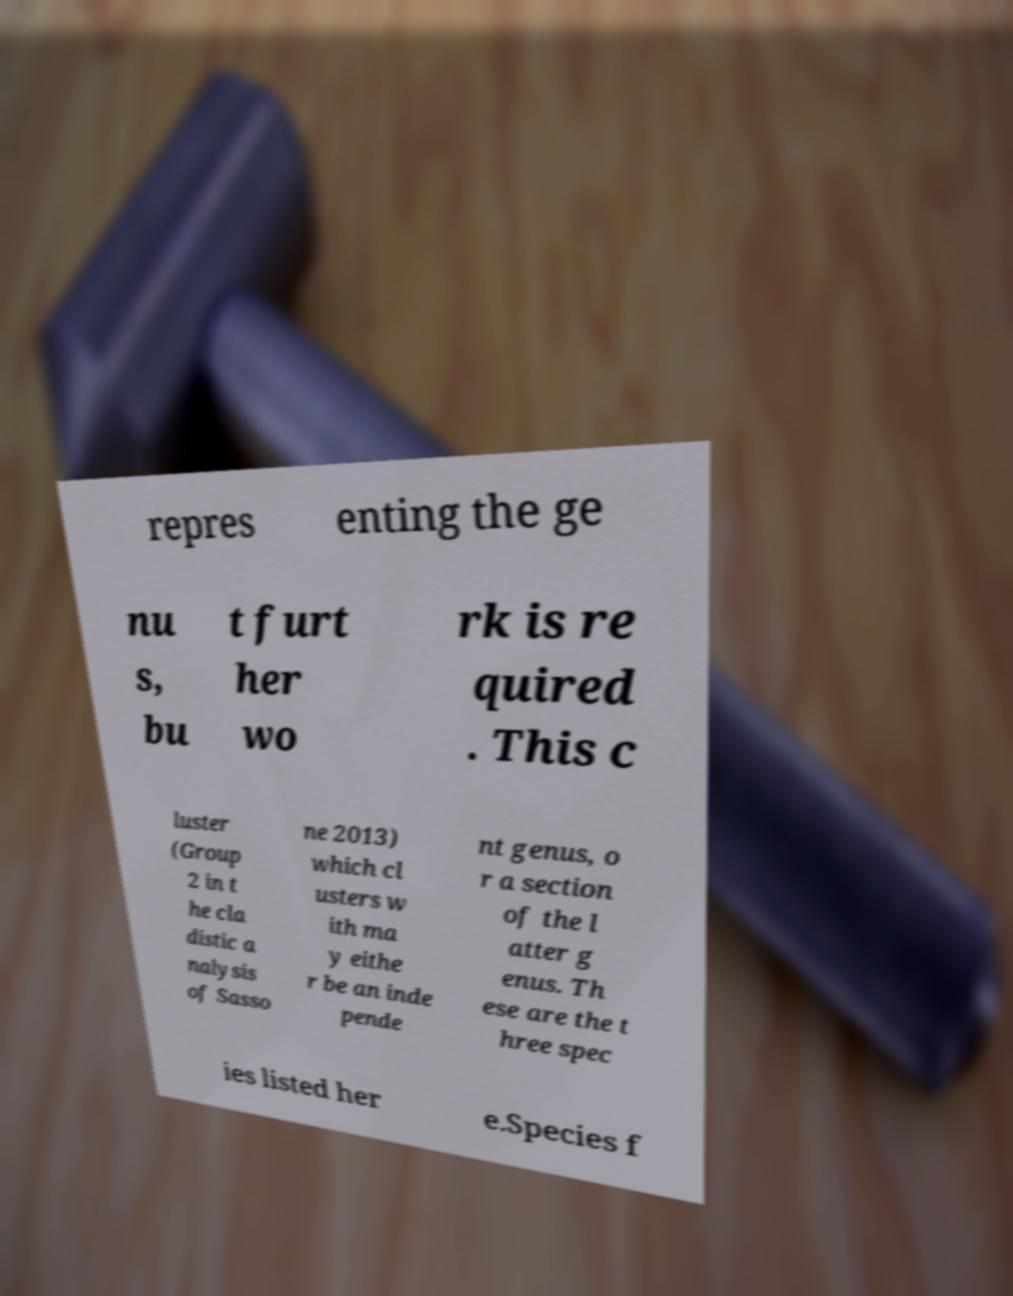I need the written content from this picture converted into text. Can you do that? repres enting the ge nu s, bu t furt her wo rk is re quired . This c luster (Group 2 in t he cla distic a nalysis of Sasso ne 2013) which cl usters w ith ma y eithe r be an inde pende nt genus, o r a section of the l atter g enus. Th ese are the t hree spec ies listed her e.Species f 